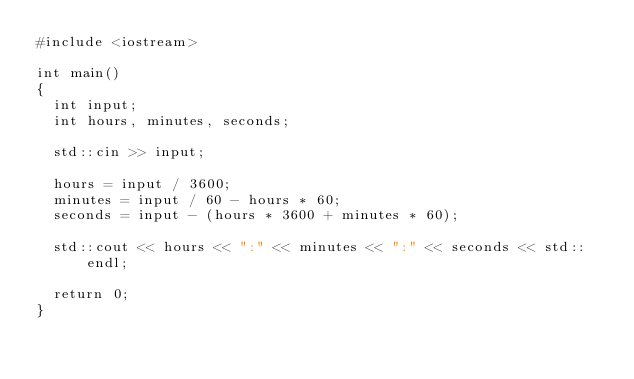Convert code to text. <code><loc_0><loc_0><loc_500><loc_500><_C++_>#include <iostream>

int main()
{
	int input;
	int hours, minutes, seconds;

	std::cin >> input;

	hours = input / 3600;
	minutes = input / 60 - hours * 60;
	seconds = input - (hours * 3600 + minutes * 60);
	
	std::cout << hours << ":" << minutes << ":" << seconds << std::endl;

	return 0;
}


</code> 